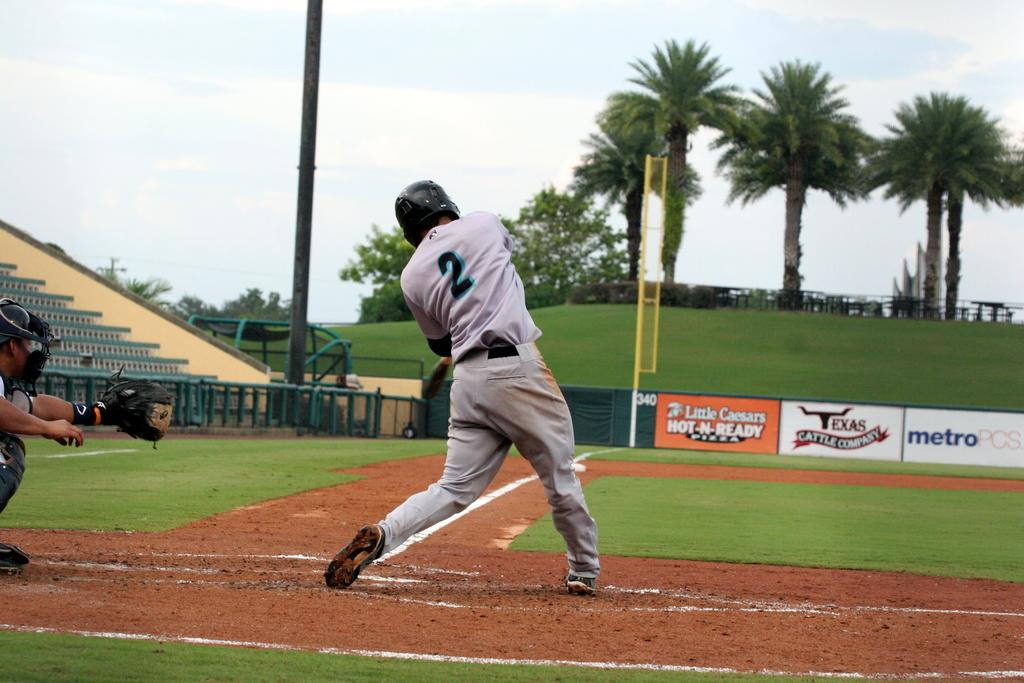<image>
Render a clear and concise summary of the photo. Player number 2 is at bat and taking a swing. 